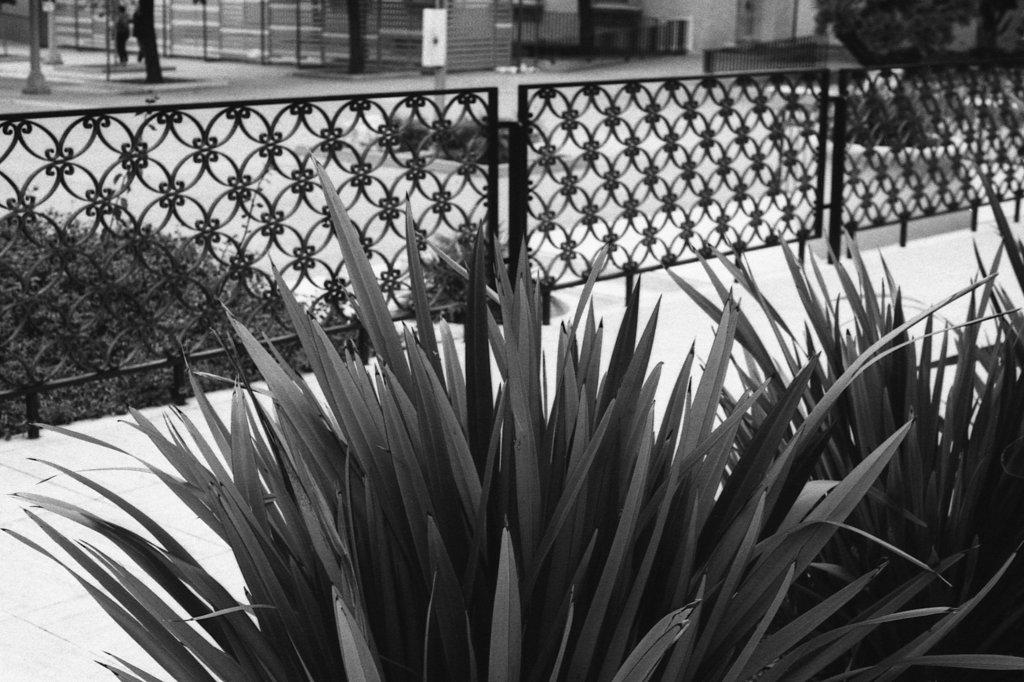What type of living organisms can be seen in the image? Plants can be seen in the image. What type of structure is present in the image? There is a fence in the image. What is visible beneath the plants and fence? The ground is visible in the image. What else can be seen in the image besides plants and a fence? There are poles and some unspecified objects in the image. How many trucks are parked near the plants in the image? There are no trucks present in the image. What type of seat can be seen in the image? There is no seat present in the image. 